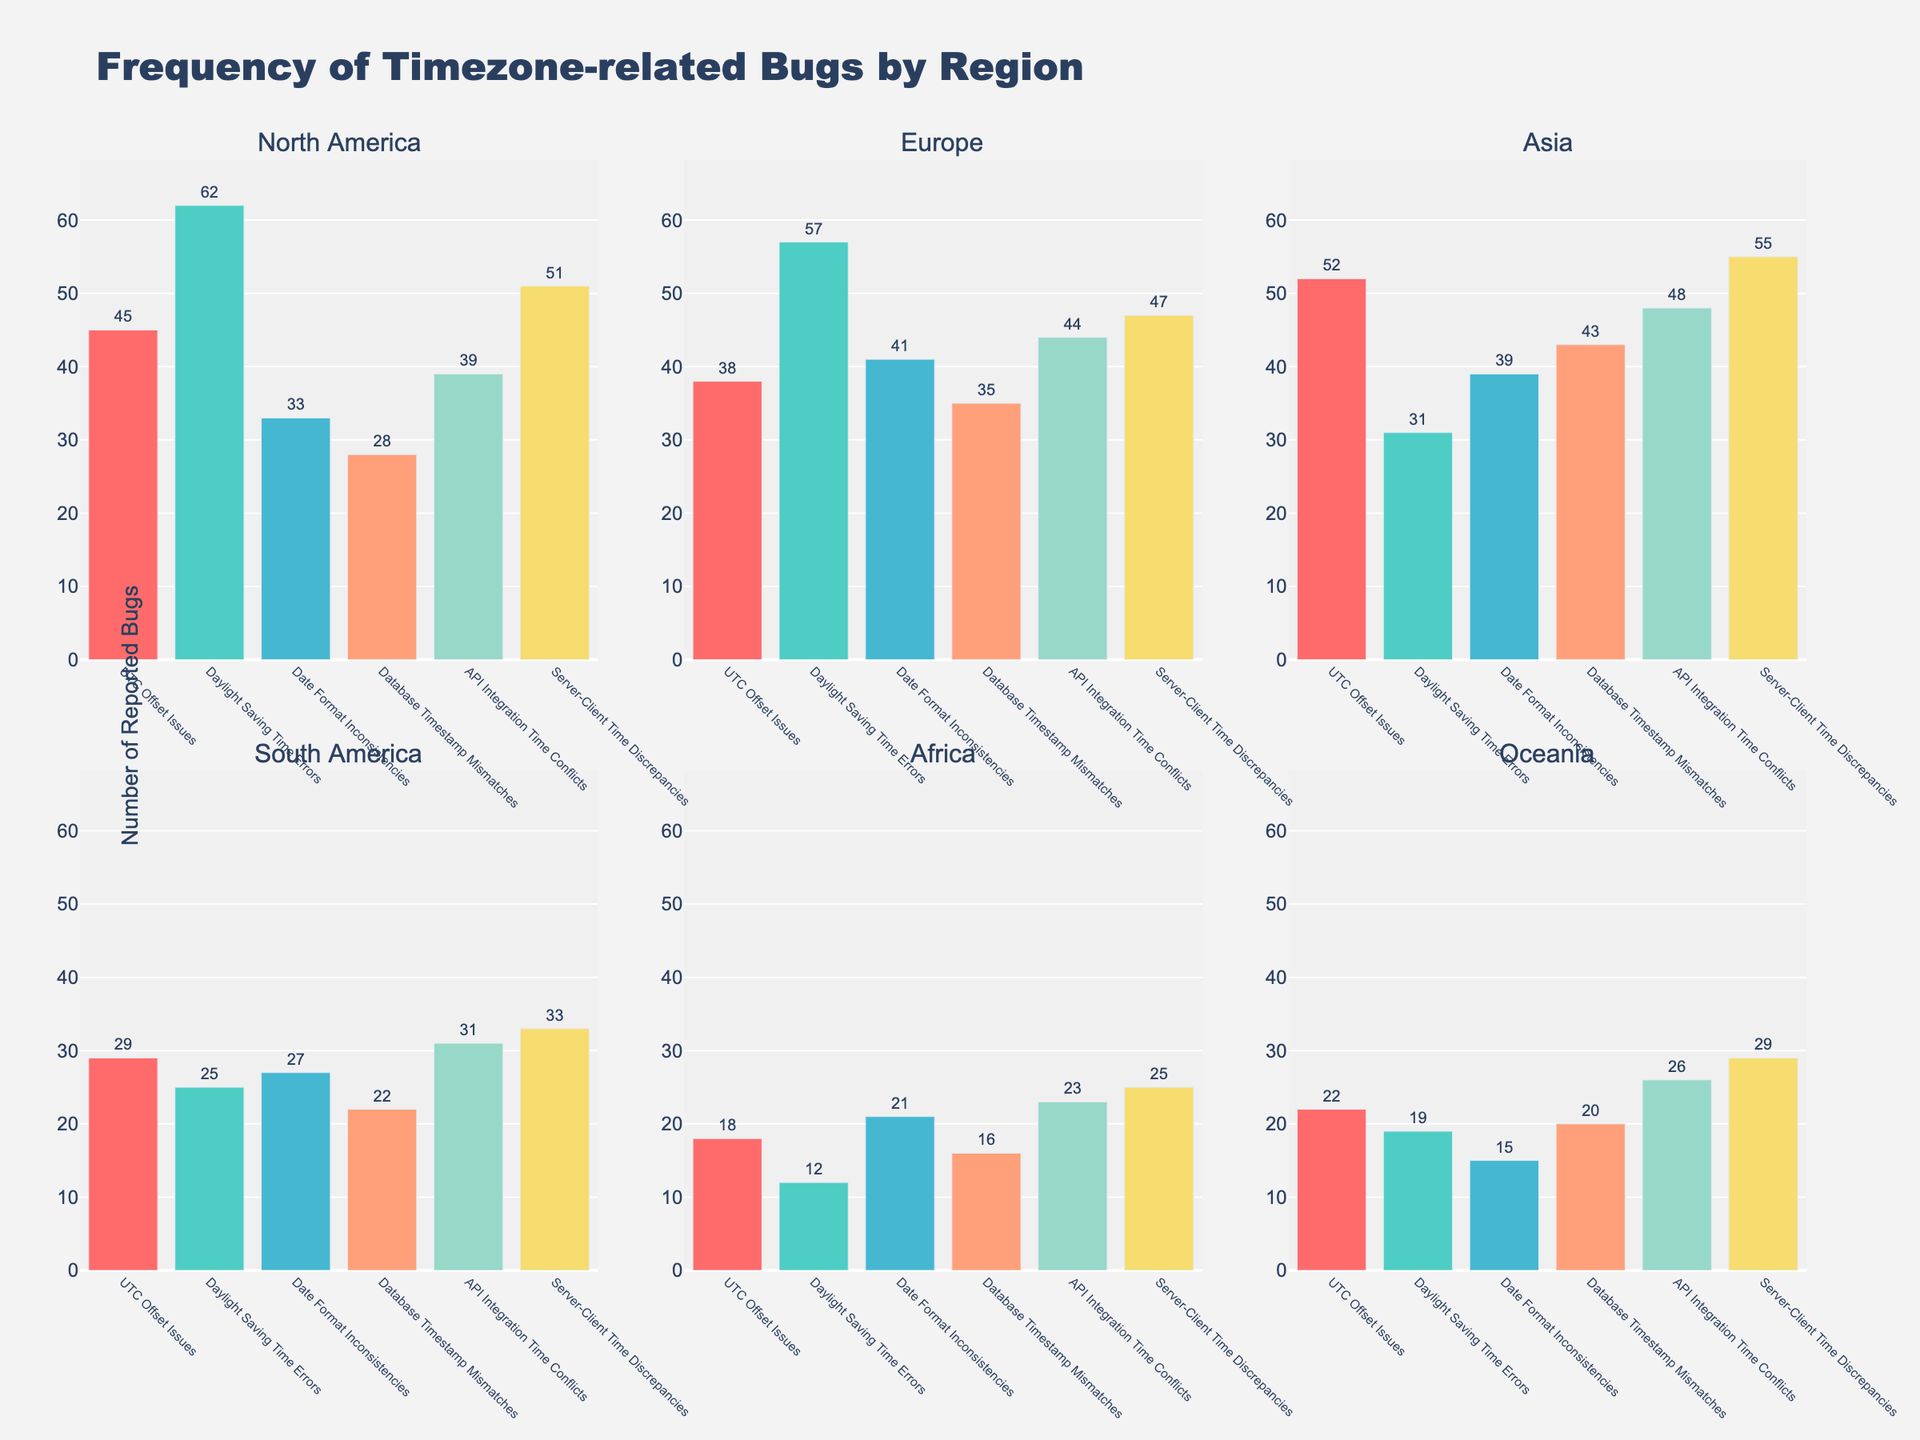What's the title of the figure? The title of the figure is generally written at the top center. We can see it prominently displayed there.
Answer: Frequency of Timezone-related Bugs by Region How many subplots are there in the figure? You can count the number of subplots present in the figure. They are usually divided by borders.
Answer: 6 What color is used for the 'UTC Offset Issues' bar in each subplot? Identifying the color used for 'UTC Offset Issues' involves comparing the colors of the bars to the custom color palette mentioned. The first color in the list is used for 'UTC Offset Issues'.
Answer: Red Which region has the highest number of 'Daylight Saving Time Errors' reported? Look at the height of the 'Daylight Saving Time Errors' bar in each subplot. The one that stands the tallest has the highest number.
Answer: North America What is the total number of 'API Integration Time Conflicts' reported across all regions? Sum the 'API Integration Time Conflicts' values from each region. The values are 39, 44, 48, 31, 23, and 26. Adding these together gives the total.
Answer: 211 How many more 'Server-Client Time Discrepancies' are reported in Asia compared to Europe? Subtract the number of 'Server-Client Time Discrepancies' reported in Europe (47) from the number reported in Asia (55). The difference is 55 - 47.
Answer: 8 Which region has the lowest number of 'Date Format Inconsistencies' reported? Look for the shortest bar in the subplot corresponding to 'Date Format Inconsistencies'. The region represented by this bar is the one with the lowest cases.
Answer: Oceania Is the count of 'Database Timestamp Mismatches' greater in South America or Oceania? Compare the heights of the 'Database Timestamp Mismatches' bars for South America (22) and Oceania (20). The region with the taller bar has the greater count.
Answer: South America What is the average number of 'UTC Offset Issues' reported across all regions? Sum the 'UTC Offset Issues' values for all regions (45 + 38 + 52 + 29 + 18 + 22) and then divide by the number of regions (6). The calculation is (204 / 6).
Answer: 34 Compare the number of 'Daylight Saving Time Errors' to 'UTC Offset Issues' reported in Africa. Which is higher and by how much? In Africa, compare the number of 'Daylight Saving Time Errors' (12) to the number of 'UTC Offset Issues' (18). Subtract the smaller value from the larger one to find the difference (18 - 12).
Answer: UTC Offset Issues are higher by 6 